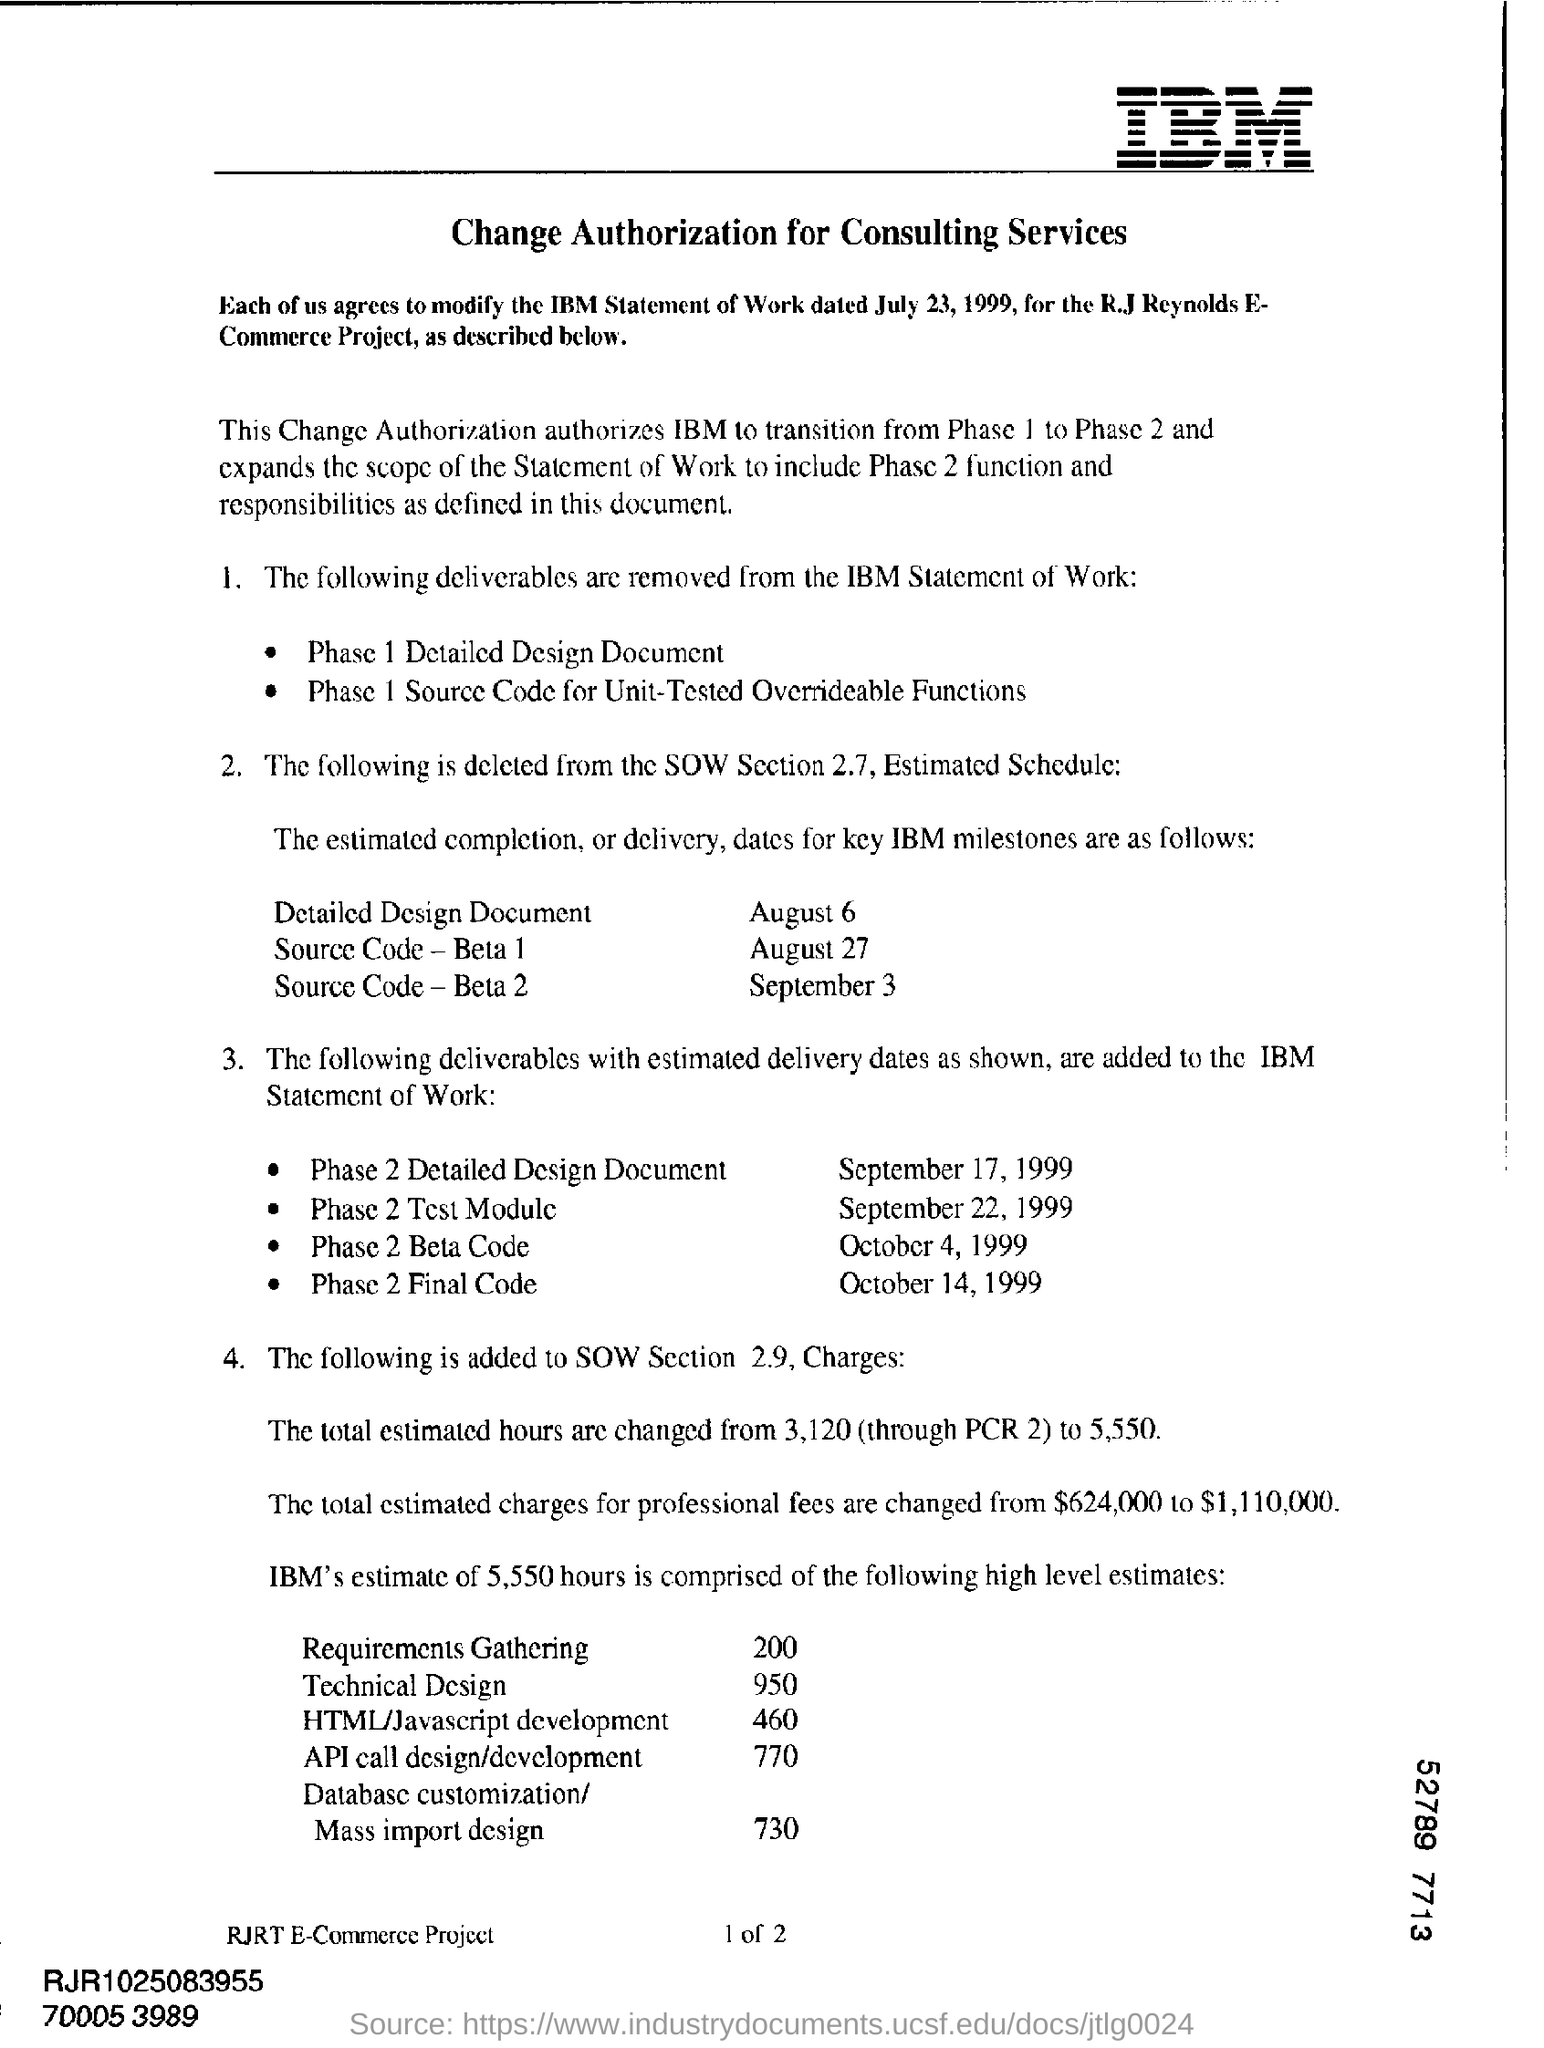Draw attention to some important aspects in this diagram. The estimated delivery date for Phase 2 Test Module is September 22, 1999. The deliverable that needs to be delivered on October 4, 1999, is Phase 2 Beta Code. The total estimated charges for professional fees are approximately $1,110,000. The completion of Source Code-Beta 1 is scheduled for August 27. 